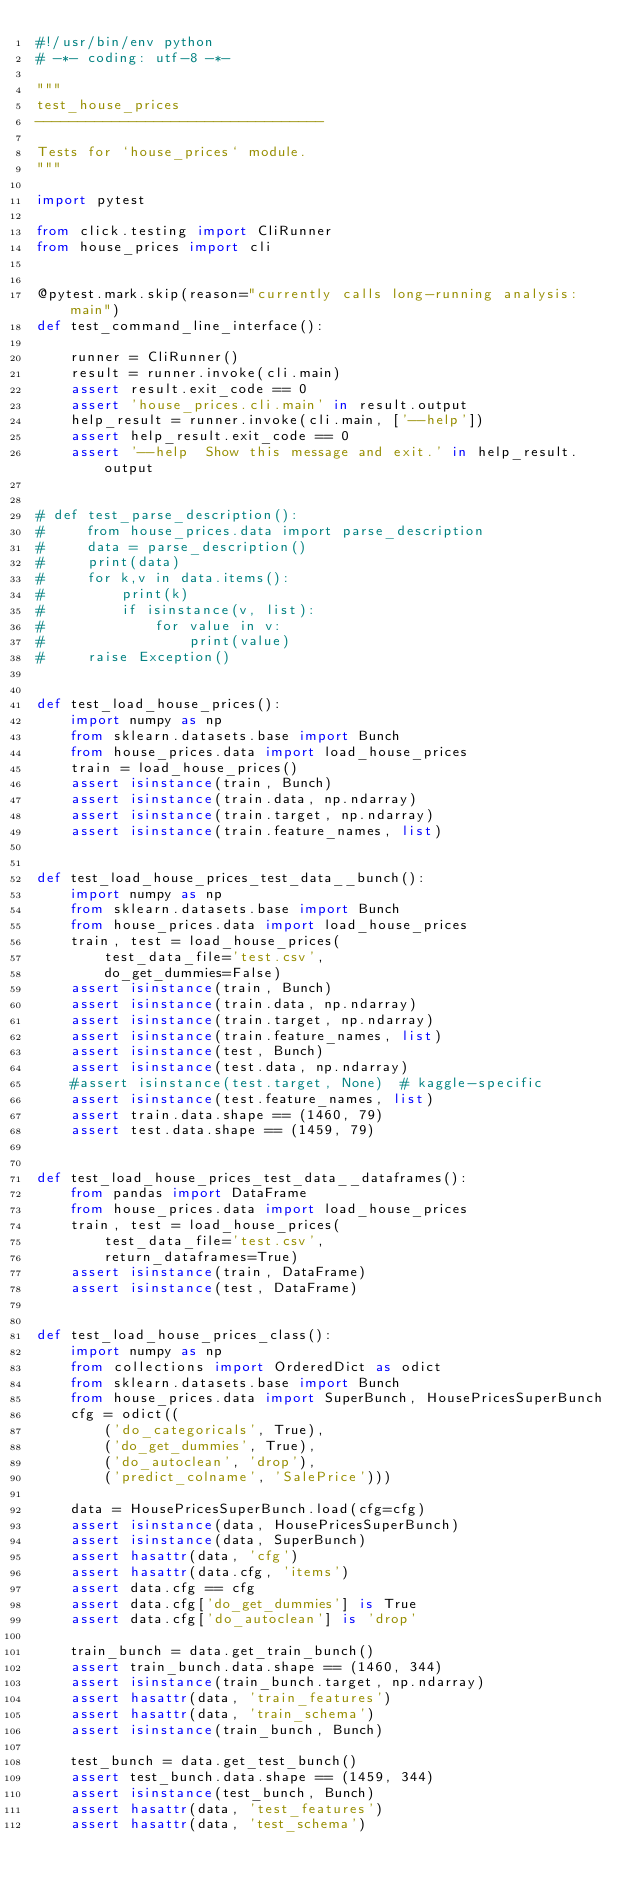Convert code to text. <code><loc_0><loc_0><loc_500><loc_500><_Python_>#!/usr/bin/env python
# -*- coding: utf-8 -*-

"""
test_house_prices
----------------------------------

Tests for `house_prices` module.
"""

import pytest

from click.testing import CliRunner
from house_prices import cli


@pytest.mark.skip(reason="currently calls long-running analysis:main")
def test_command_line_interface():

    runner = CliRunner()
    result = runner.invoke(cli.main)
    assert result.exit_code == 0
    assert 'house_prices.cli.main' in result.output
    help_result = runner.invoke(cli.main, ['--help'])
    assert help_result.exit_code == 0
    assert '--help  Show this message and exit.' in help_result.output


# def test_parse_description():
#     from house_prices.data import parse_description
#     data = parse_description()
#     print(data)
#     for k,v in data.items():
#         print(k)
#         if isinstance(v, list):
#             for value in v:
#                 print(value)
#     raise Exception()


def test_load_house_prices():
    import numpy as np
    from sklearn.datasets.base import Bunch
    from house_prices.data import load_house_prices
    train = load_house_prices()
    assert isinstance(train, Bunch)
    assert isinstance(train.data, np.ndarray)
    assert isinstance(train.target, np.ndarray)
    assert isinstance(train.feature_names, list)


def test_load_house_prices_test_data__bunch():
    import numpy as np
    from sklearn.datasets.base import Bunch
    from house_prices.data import load_house_prices
    train, test = load_house_prices(
        test_data_file='test.csv',
        do_get_dummies=False)
    assert isinstance(train, Bunch)
    assert isinstance(train.data, np.ndarray)
    assert isinstance(train.target, np.ndarray)
    assert isinstance(train.feature_names, list)
    assert isinstance(test, Bunch)
    assert isinstance(test.data, np.ndarray)
    #assert isinstance(test.target, None)  # kaggle-specific
    assert isinstance(test.feature_names, list)
    assert train.data.shape == (1460, 79)
    assert test.data.shape == (1459, 79)


def test_load_house_prices_test_data__dataframes():
    from pandas import DataFrame
    from house_prices.data import load_house_prices
    train, test = load_house_prices(
        test_data_file='test.csv',
        return_dataframes=True)
    assert isinstance(train, DataFrame)
    assert isinstance(test, DataFrame)


def test_load_house_prices_class():
    import numpy as np
    from collections import OrderedDict as odict
    from sklearn.datasets.base import Bunch
    from house_prices.data import SuperBunch, HousePricesSuperBunch
    cfg = odict((
        ('do_categoricals', True),
        ('do_get_dummies', True),
        ('do_autoclean', 'drop'),
        ('predict_colname', 'SalePrice')))

    data = HousePricesSuperBunch.load(cfg=cfg)
    assert isinstance(data, HousePricesSuperBunch)
    assert isinstance(data, SuperBunch)
    assert hasattr(data, 'cfg')
    assert hasattr(data.cfg, 'items')
    assert data.cfg == cfg
    assert data.cfg['do_get_dummies'] is True
    assert data.cfg['do_autoclean'] is 'drop'

    train_bunch = data.get_train_bunch()
    assert train_bunch.data.shape == (1460, 344)
    assert isinstance(train_bunch.target, np.ndarray)
    assert hasattr(data, 'train_features')
    assert hasattr(data, 'train_schema')
    assert isinstance(train_bunch, Bunch)

    test_bunch = data.get_test_bunch()
    assert test_bunch.data.shape == (1459, 344)
    assert isinstance(test_bunch, Bunch)
    assert hasattr(data, 'test_features')
    assert hasattr(data, 'test_schema')
</code> 